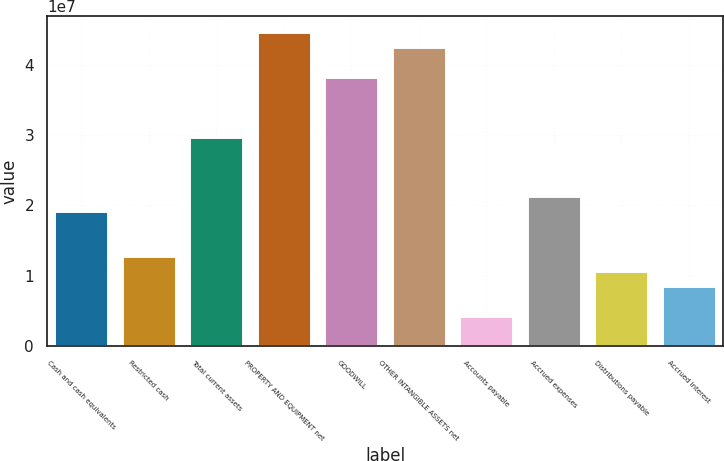<chart> <loc_0><loc_0><loc_500><loc_500><bar_chart><fcel>Cash and cash equivalents<fcel>Restricted cash<fcel>Total current assets<fcel>PROPERTY AND EQUIPMENT net<fcel>GOODWILL<fcel>OTHER INTANGIBLE ASSETS net<fcel>Accounts payable<fcel>Accrued expenses<fcel>Distributions payable<fcel>Accrued interest<nl><fcel>1.91372e+07<fcel>1.27582e+07<fcel>2.9769e+07<fcel>4.46534e+07<fcel>3.82744e+07<fcel>4.25271e+07<fcel>4.25276e+06<fcel>2.12636e+07<fcel>1.06318e+07<fcel>8.50546e+06<nl></chart> 